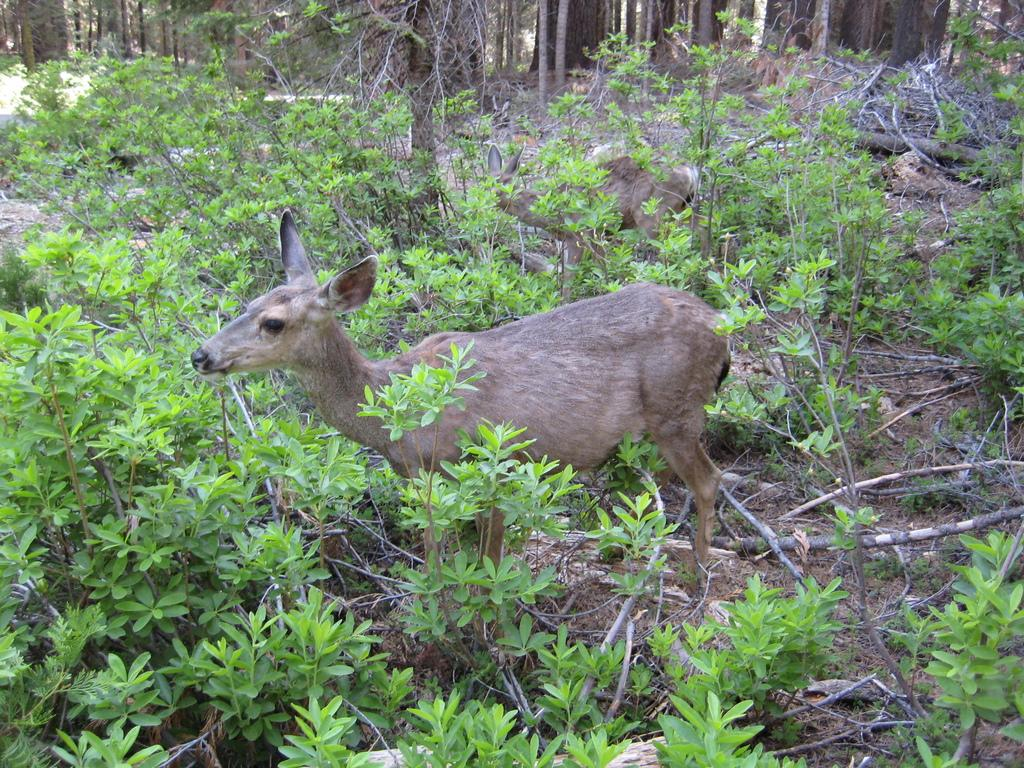What can be seen on the ground in the image? There are two animals on the ground. What is visible in the foreground of the image? There are plants in the foreground. What can be seen in the background of the image? There are wood logs and a group of trees in the background. What type of ring is being worn by the animals in the image? There are no rings visible on the animals in the image. Is there an army present in the image? There is no army present in the image. 